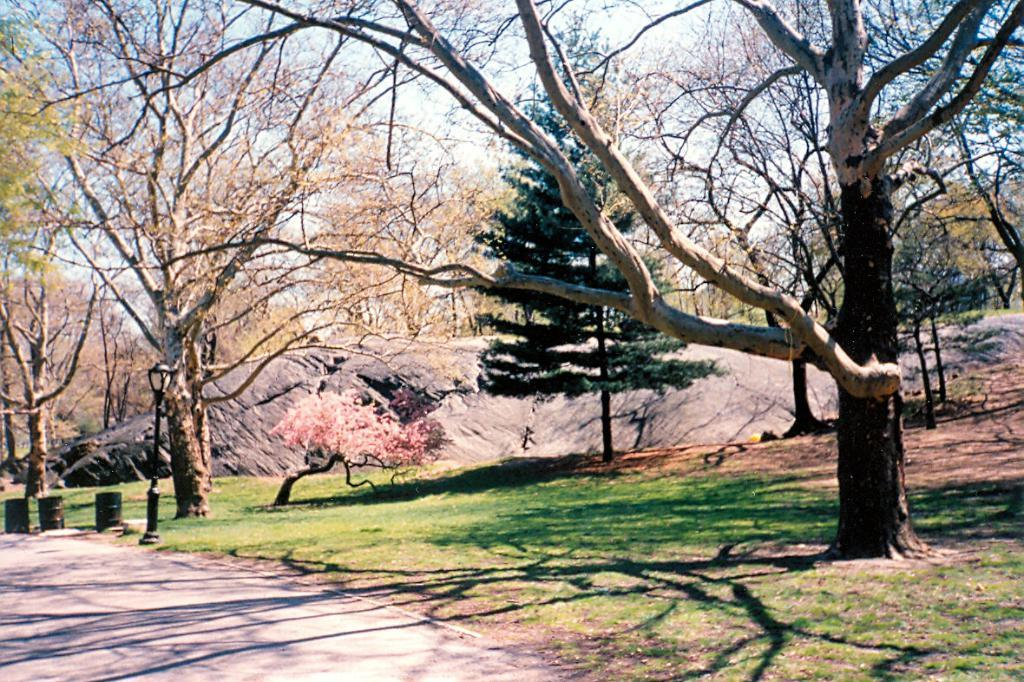What type of vegetation can be seen in the image? There are trees in the image. What type of natural landform is visible in the image? There are mountains in the image. What type of ground cover is present in the image? There is grass in the image. What man-made objects can be seen in the image? There are barrels and poles in the image. What part of the natural environment is visible in the image? The sky is visible at the top of the image. What might be the location of the image? The image may have been taken in a park. What type of cushion is being used to support the mountains in the image? There is no cushion present in the image, and the mountains are not supported by any cushion. What direction are the poles turning in the image? The poles are not turning in the image; they are stationary. 